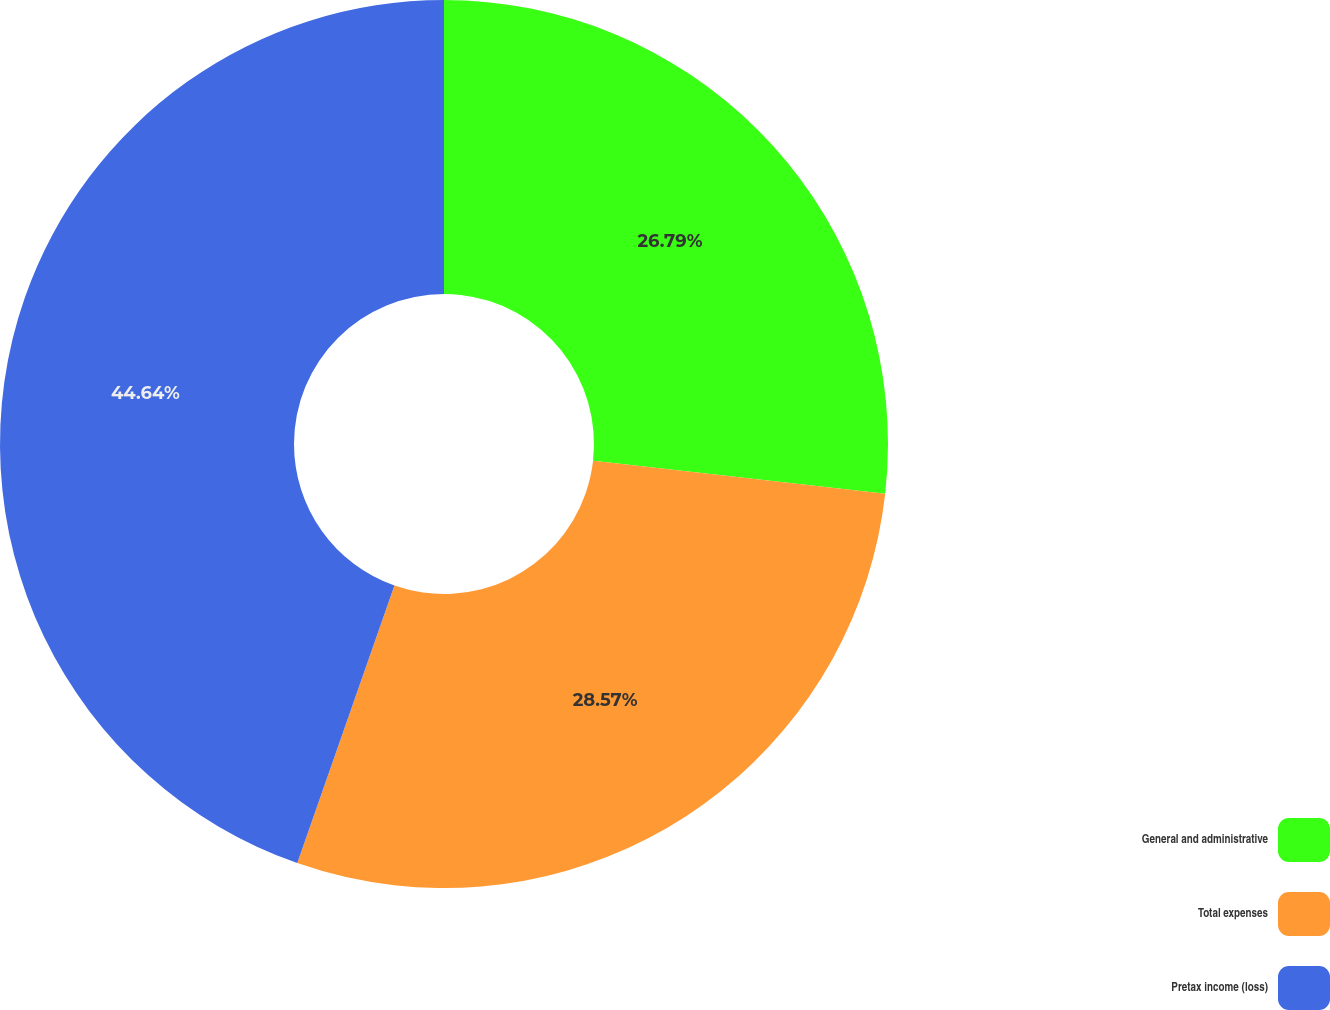<chart> <loc_0><loc_0><loc_500><loc_500><pie_chart><fcel>General and administrative<fcel>Total expenses<fcel>Pretax income (loss)<nl><fcel>26.79%<fcel>28.57%<fcel>44.64%<nl></chart> 